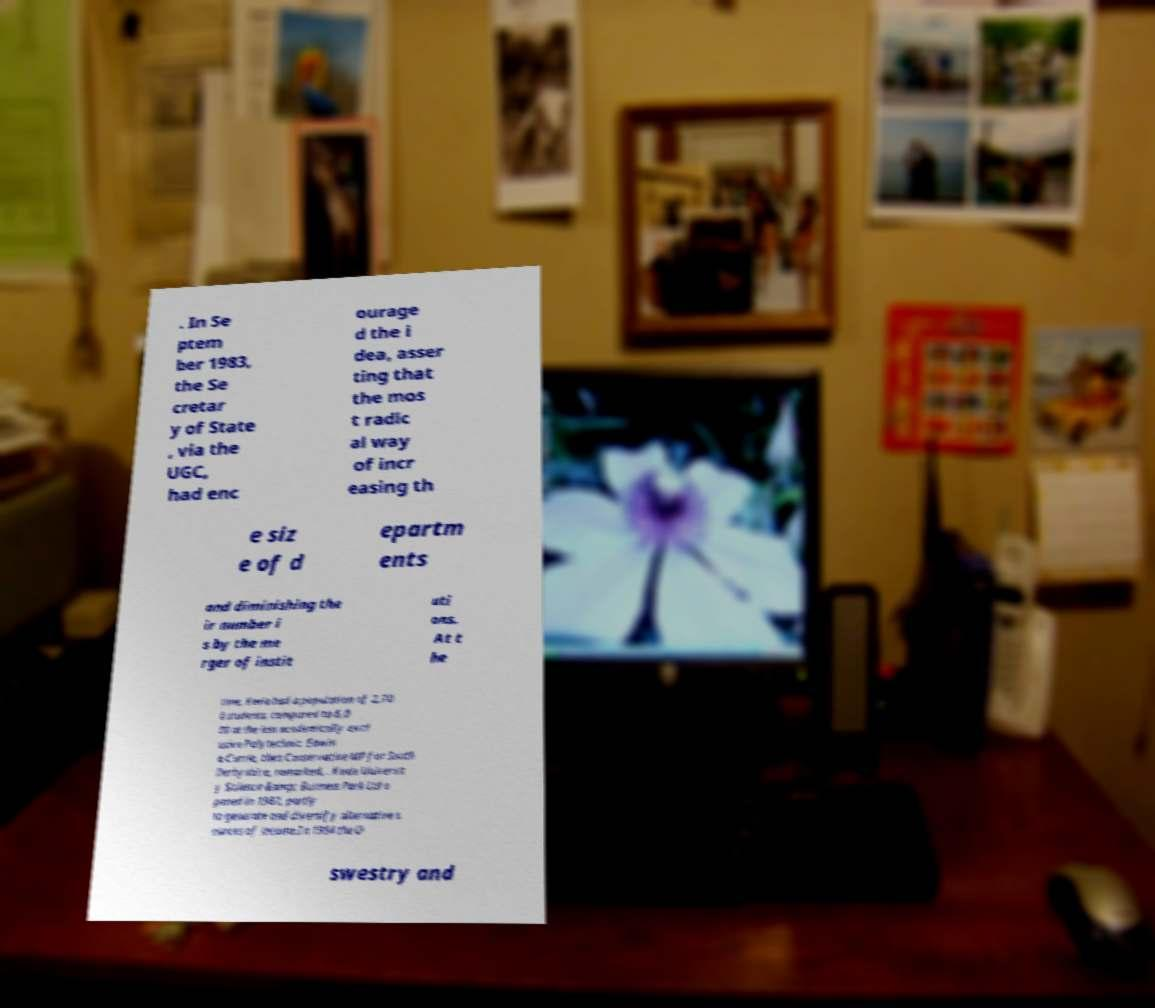Can you read and provide the text displayed in the image?This photo seems to have some interesting text. Can you extract and type it out for me? . In Se ptem ber 1983, the Se cretar y of State , via the UGC, had enc ourage d the i dea, asser ting that the mos t radic al way of incr easing th e siz e of d epartm ents and diminishing the ir number i s by the me rger of instit uti ons. At t he time, Keele had a population of 2,70 0 students, compared to 6,0 00 at the less academically excl usive Polytechnic. Edwin a Currie, then Conservative MP for South Derbyshire, remarked, . Keele Universit y Science &amp; Business Park Ltd o pened in 1987, partly to generate and diversify alternative s ources of income.In 1994 the O swestry and 